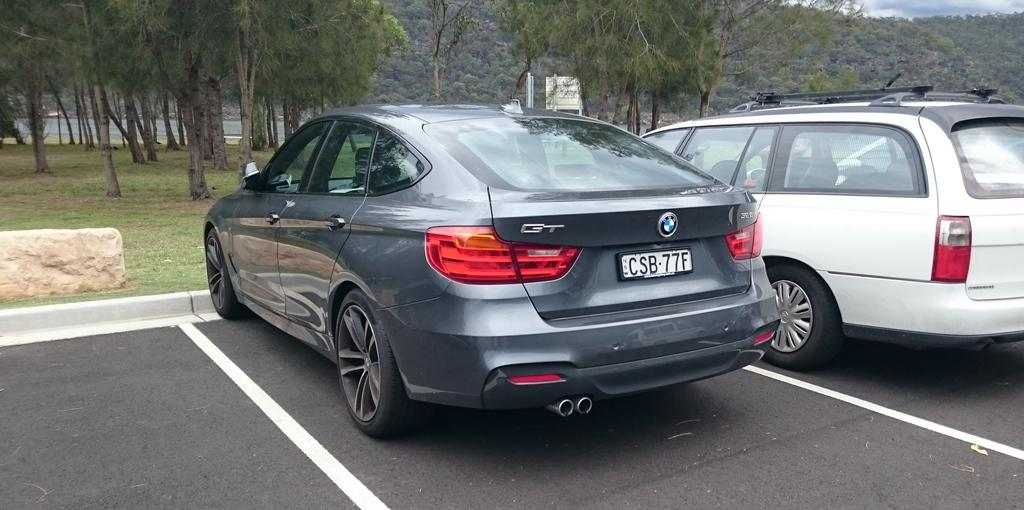What can be seen on the road in the image? There are cars parked on the road in the image. What is the ground surface like in the image? The ground is covered with grass. What can be seen in the background of the image? There are trees and hills covered with trees visible in the background. How many clocks are hanging from the trees in the image? There are no clocks hanging from the trees in the image. What type of lip can be seen on the cars in the image? There are no lips present in the image; it features cars parked on the road. 